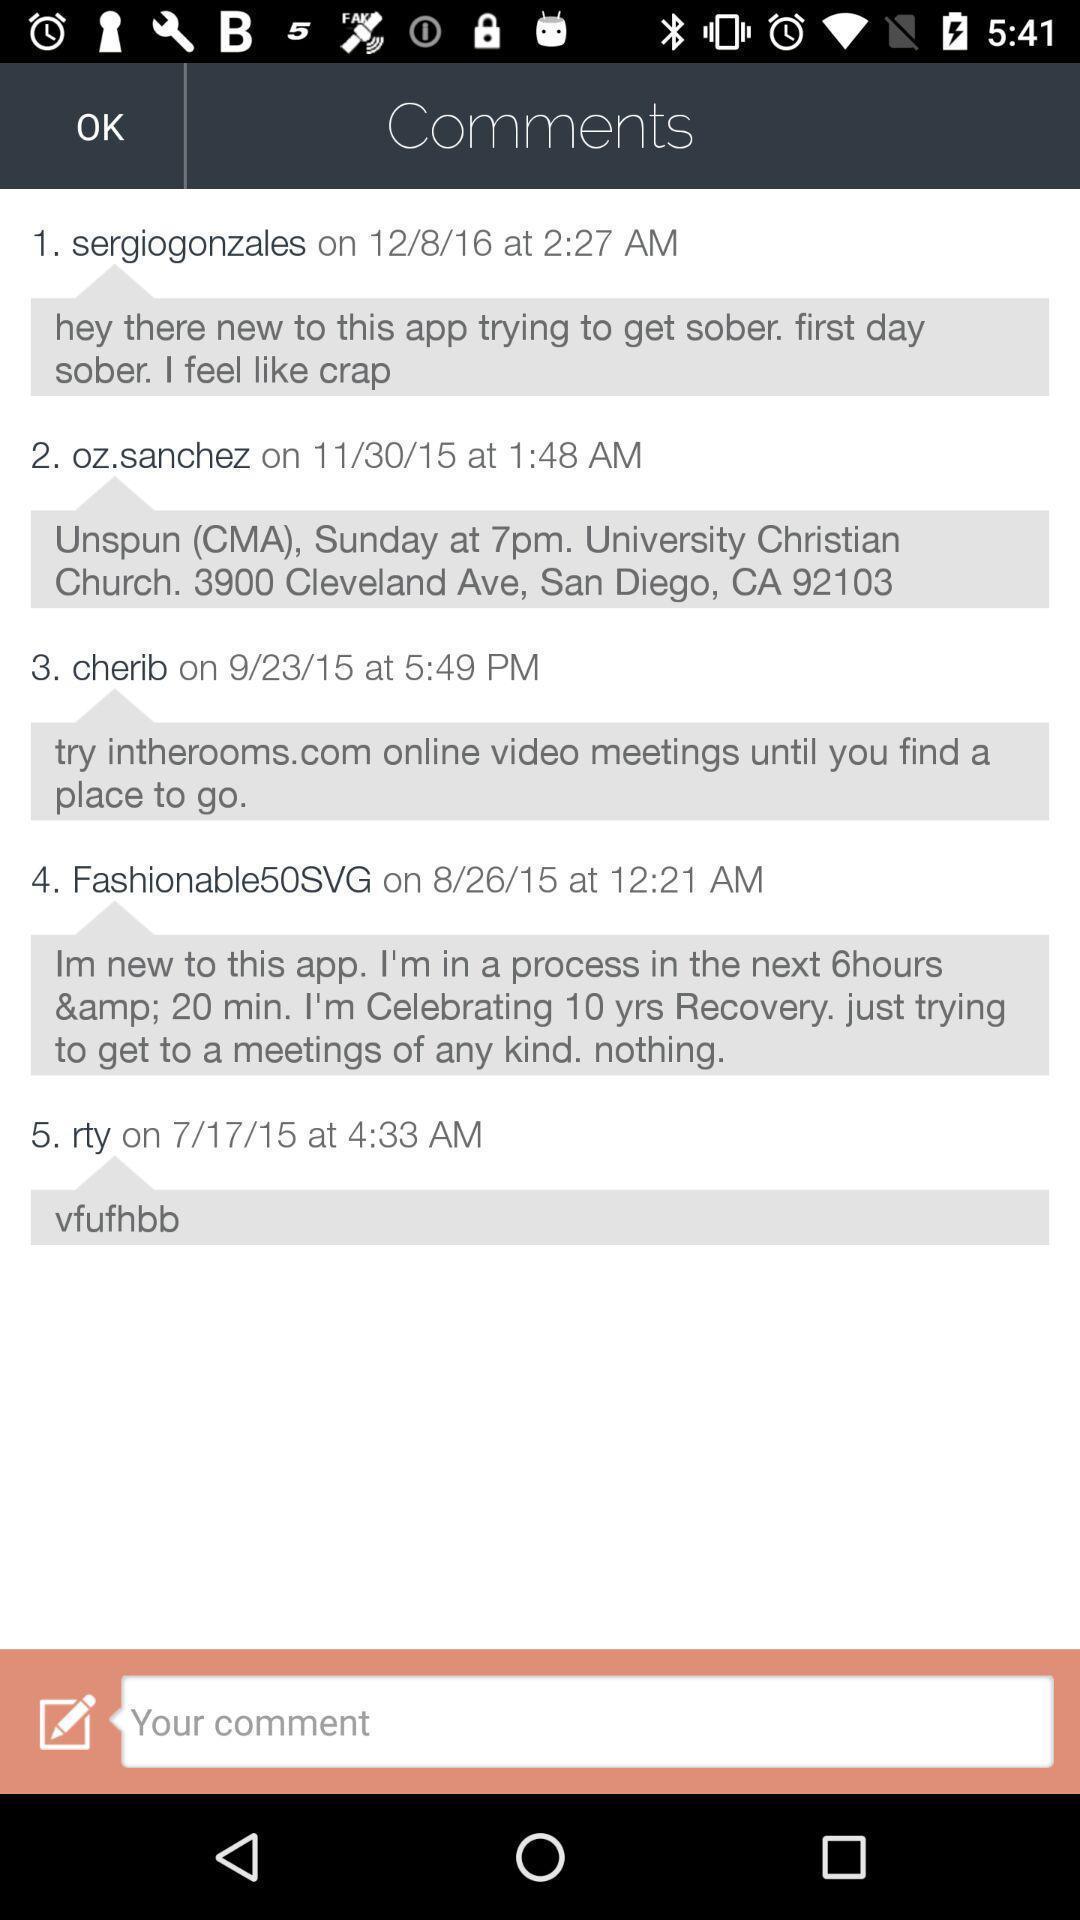Provide a textual representation of this image. Window displaying a comment section. 